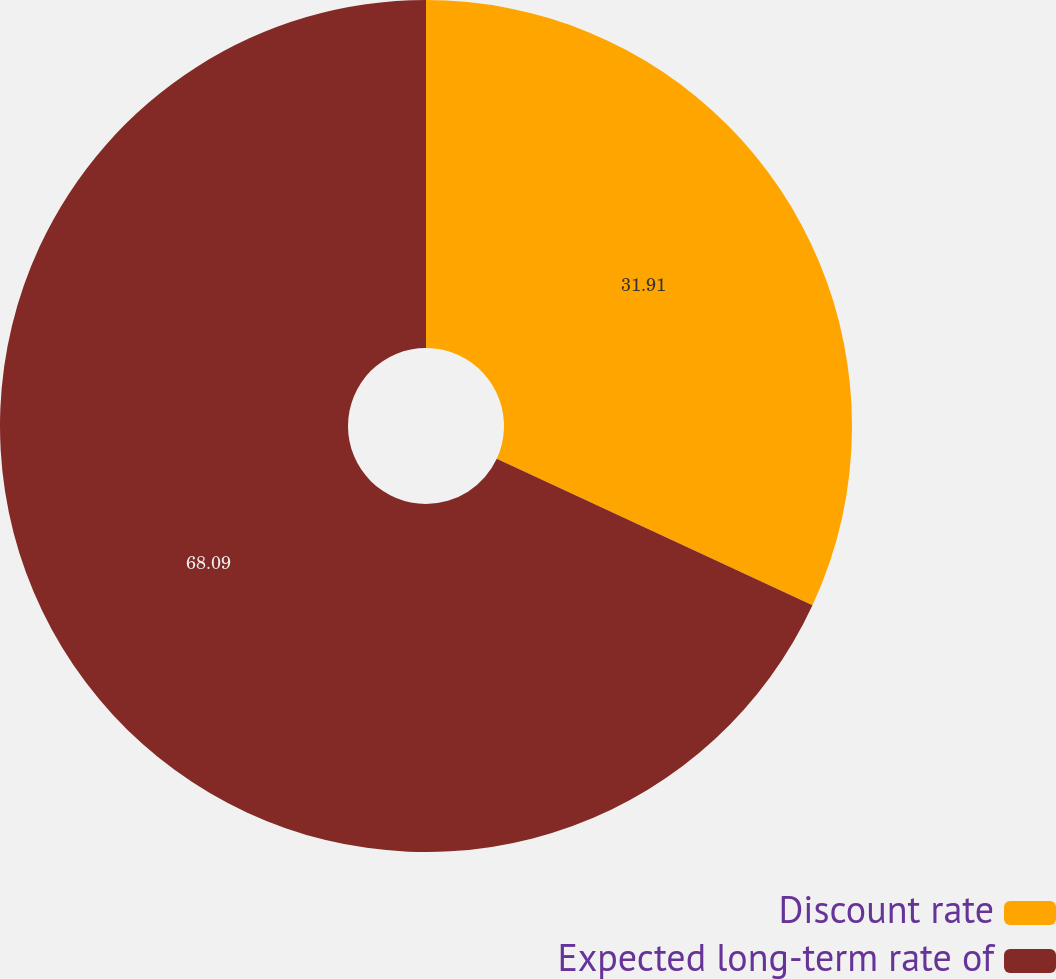Convert chart. <chart><loc_0><loc_0><loc_500><loc_500><pie_chart><fcel>Discount rate<fcel>Expected long-term rate of<nl><fcel>31.91%<fcel>68.09%<nl></chart> 